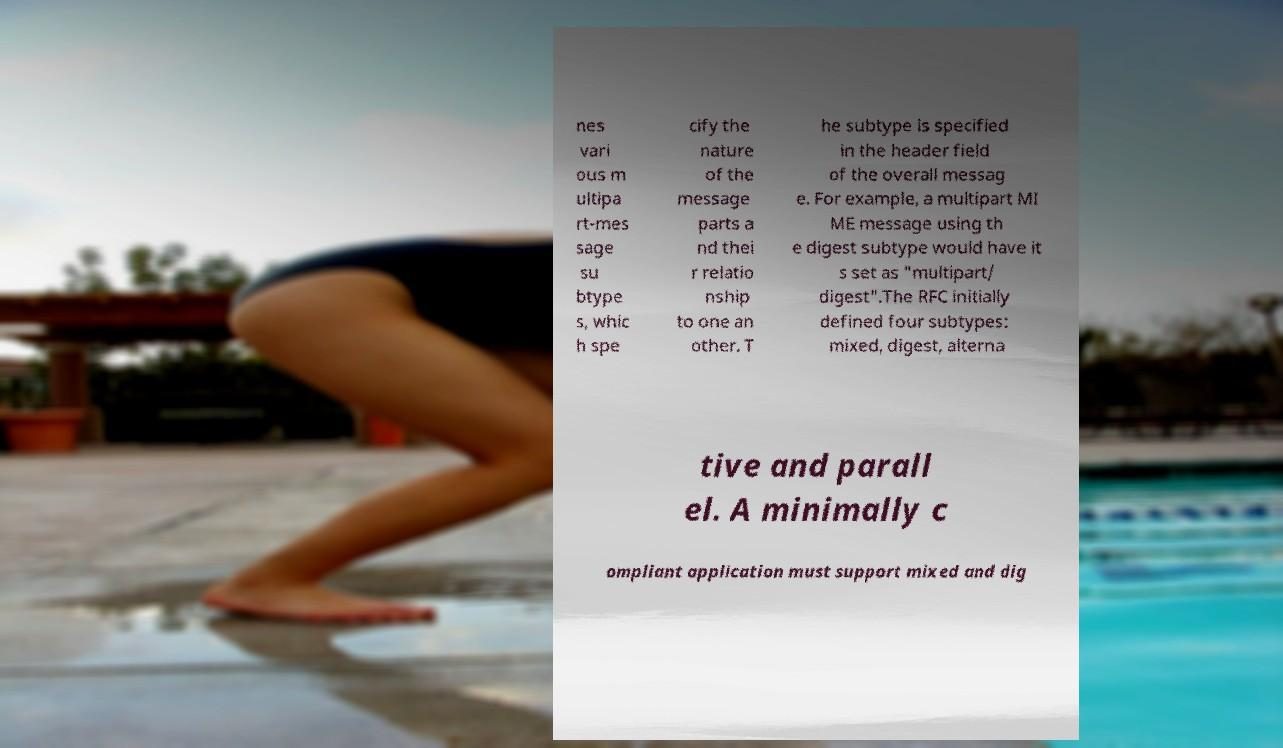Could you assist in decoding the text presented in this image and type it out clearly? nes vari ous m ultipa rt-mes sage su btype s, whic h spe cify the nature of the message parts a nd thei r relatio nship to one an other. T he subtype is specified in the header field of the overall messag e. For example, a multipart MI ME message using th e digest subtype would have it s set as "multipart/ digest".The RFC initially defined four subtypes: mixed, digest, alterna tive and parall el. A minimally c ompliant application must support mixed and dig 